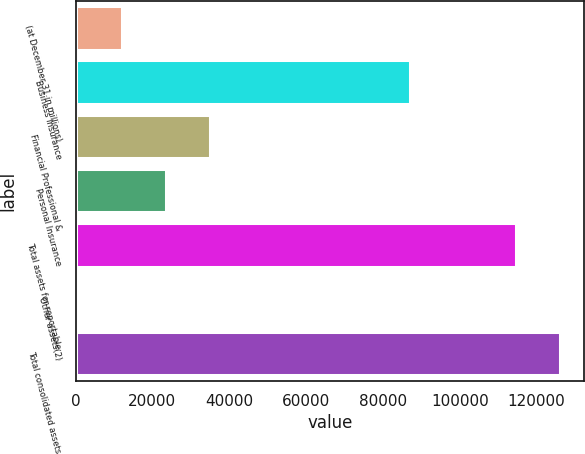Convert chart to OTSL. <chart><loc_0><loc_0><loc_500><loc_500><bar_chart><fcel>(at December 31 in millions)<fcel>Business Insurance<fcel>Financial Professional &<fcel>Personal Insurance<fcel>Total assets for reportable<fcel>Other assets(2)<fcel>Total consolidated assets<nl><fcel>12120.9<fcel>87160<fcel>35032.7<fcel>23576.8<fcel>114559<fcel>665<fcel>126015<nl></chart> 